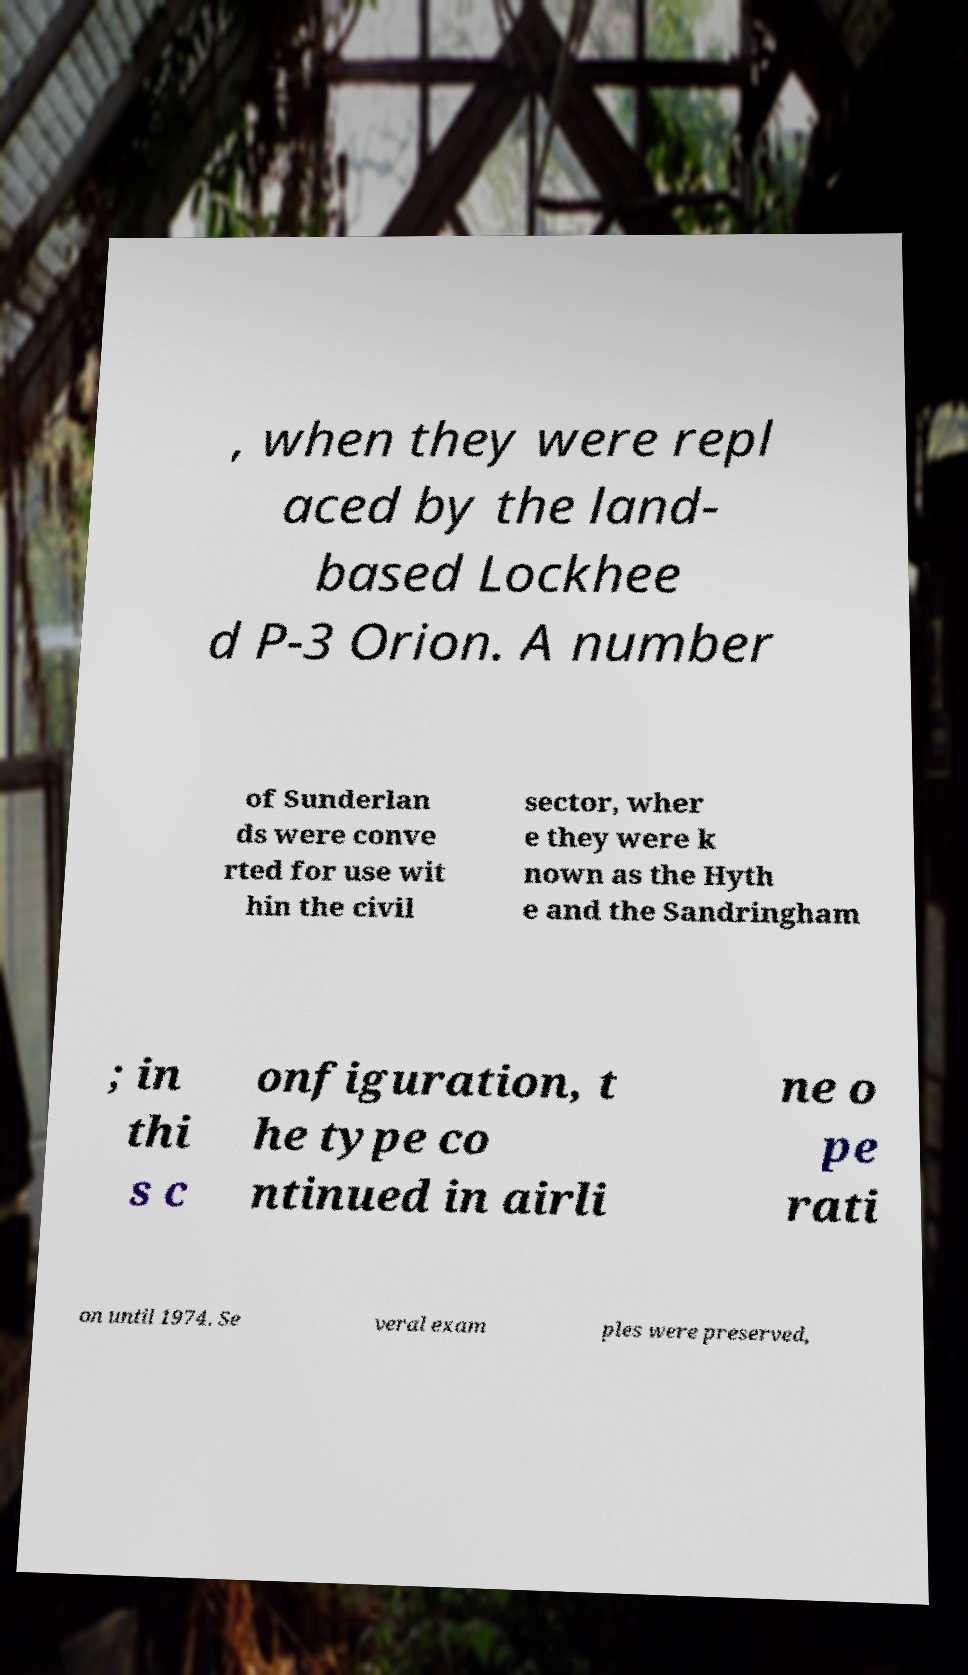Could you extract and type out the text from this image? , when they were repl aced by the land- based Lockhee d P-3 Orion. A number of Sunderlan ds were conve rted for use wit hin the civil sector, wher e they were k nown as the Hyth e and the Sandringham ; in thi s c onfiguration, t he type co ntinued in airli ne o pe rati on until 1974. Se veral exam ples were preserved, 